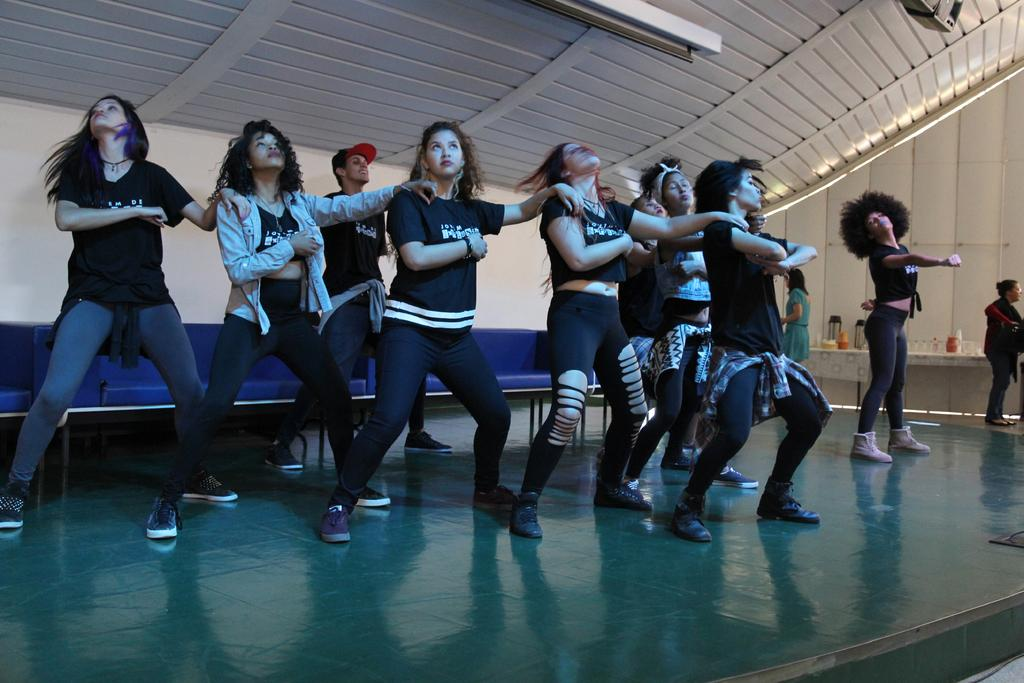What are the ladies in the image doing? The ladies are dancing in the center of the image. Where are the ladies dancing? The ladies are dancing on the floor. What can be seen in the background of the image? There is a sofa and a wall visible in the background of the image. What type of agreement is being discussed by the birds in the image? There are no birds present in the image, so there is no discussion of any agreement. 